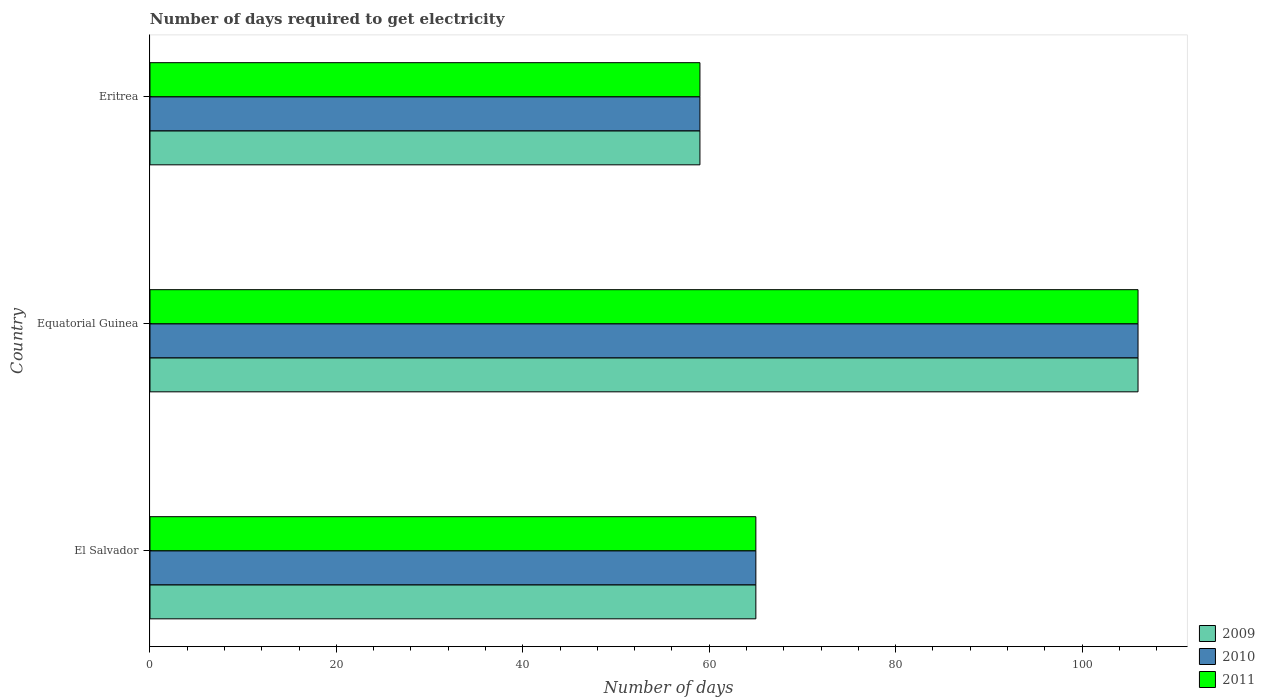How many different coloured bars are there?
Provide a short and direct response. 3. How many groups of bars are there?
Keep it short and to the point. 3. How many bars are there on the 2nd tick from the top?
Make the answer very short. 3. How many bars are there on the 2nd tick from the bottom?
Keep it short and to the point. 3. What is the label of the 3rd group of bars from the top?
Your response must be concise. El Salvador. Across all countries, what is the maximum number of days required to get electricity in in 2010?
Give a very brief answer. 106. Across all countries, what is the minimum number of days required to get electricity in in 2010?
Your response must be concise. 59. In which country was the number of days required to get electricity in in 2010 maximum?
Offer a terse response. Equatorial Guinea. In which country was the number of days required to get electricity in in 2010 minimum?
Give a very brief answer. Eritrea. What is the total number of days required to get electricity in in 2009 in the graph?
Ensure brevity in your answer.  230. What is the difference between the number of days required to get electricity in in 2009 in El Salvador and that in Equatorial Guinea?
Make the answer very short. -41. What is the difference between the number of days required to get electricity in in 2009 in Equatorial Guinea and the number of days required to get electricity in in 2011 in El Salvador?
Keep it short and to the point. 41. What is the average number of days required to get electricity in in 2009 per country?
Offer a very short reply. 76.67. In how many countries, is the number of days required to get electricity in in 2010 greater than 36 days?
Provide a short and direct response. 3. What is the ratio of the number of days required to get electricity in in 2009 in El Salvador to that in Equatorial Guinea?
Offer a terse response. 0.61. Is the number of days required to get electricity in in 2011 in El Salvador less than that in Eritrea?
Provide a short and direct response. No. What is the difference between the highest and the lowest number of days required to get electricity in in 2010?
Your answer should be very brief. 47. In how many countries, is the number of days required to get electricity in in 2011 greater than the average number of days required to get electricity in in 2011 taken over all countries?
Provide a succinct answer. 1. Is it the case that in every country, the sum of the number of days required to get electricity in in 2010 and number of days required to get electricity in in 2009 is greater than the number of days required to get electricity in in 2011?
Your answer should be very brief. Yes. How many bars are there?
Ensure brevity in your answer.  9. Does the graph contain any zero values?
Keep it short and to the point. No. How are the legend labels stacked?
Provide a succinct answer. Vertical. What is the title of the graph?
Your response must be concise. Number of days required to get electricity. What is the label or title of the X-axis?
Make the answer very short. Number of days. What is the label or title of the Y-axis?
Give a very brief answer. Country. What is the Number of days of 2009 in Equatorial Guinea?
Offer a very short reply. 106. What is the Number of days in 2010 in Equatorial Guinea?
Make the answer very short. 106. What is the Number of days of 2011 in Equatorial Guinea?
Give a very brief answer. 106. What is the Number of days in 2009 in Eritrea?
Give a very brief answer. 59. What is the Number of days of 2010 in Eritrea?
Your response must be concise. 59. What is the Number of days of 2011 in Eritrea?
Provide a succinct answer. 59. Across all countries, what is the maximum Number of days of 2009?
Ensure brevity in your answer.  106. Across all countries, what is the maximum Number of days in 2010?
Your answer should be compact. 106. Across all countries, what is the maximum Number of days of 2011?
Your response must be concise. 106. Across all countries, what is the minimum Number of days of 2009?
Make the answer very short. 59. Across all countries, what is the minimum Number of days in 2010?
Provide a succinct answer. 59. What is the total Number of days of 2009 in the graph?
Make the answer very short. 230. What is the total Number of days in 2010 in the graph?
Ensure brevity in your answer.  230. What is the total Number of days in 2011 in the graph?
Provide a succinct answer. 230. What is the difference between the Number of days of 2009 in El Salvador and that in Equatorial Guinea?
Your answer should be very brief. -41. What is the difference between the Number of days in 2010 in El Salvador and that in Equatorial Guinea?
Your answer should be compact. -41. What is the difference between the Number of days of 2011 in El Salvador and that in Equatorial Guinea?
Your response must be concise. -41. What is the difference between the Number of days of 2009 in El Salvador and that in Eritrea?
Make the answer very short. 6. What is the difference between the Number of days of 2011 in El Salvador and that in Eritrea?
Your response must be concise. 6. What is the difference between the Number of days of 2009 in Equatorial Guinea and that in Eritrea?
Give a very brief answer. 47. What is the difference between the Number of days in 2010 in Equatorial Guinea and that in Eritrea?
Offer a terse response. 47. What is the difference between the Number of days of 2011 in Equatorial Guinea and that in Eritrea?
Give a very brief answer. 47. What is the difference between the Number of days in 2009 in El Salvador and the Number of days in 2010 in Equatorial Guinea?
Keep it short and to the point. -41. What is the difference between the Number of days in 2009 in El Salvador and the Number of days in 2011 in Equatorial Guinea?
Provide a short and direct response. -41. What is the difference between the Number of days of 2010 in El Salvador and the Number of days of 2011 in Equatorial Guinea?
Offer a terse response. -41. What is the difference between the Number of days in 2009 in El Salvador and the Number of days in 2010 in Eritrea?
Offer a terse response. 6. What is the difference between the Number of days of 2010 in El Salvador and the Number of days of 2011 in Eritrea?
Make the answer very short. 6. What is the difference between the Number of days in 2009 in Equatorial Guinea and the Number of days in 2010 in Eritrea?
Offer a terse response. 47. What is the difference between the Number of days of 2010 in Equatorial Guinea and the Number of days of 2011 in Eritrea?
Your response must be concise. 47. What is the average Number of days of 2009 per country?
Keep it short and to the point. 76.67. What is the average Number of days in 2010 per country?
Your response must be concise. 76.67. What is the average Number of days of 2011 per country?
Your answer should be very brief. 76.67. What is the difference between the Number of days in 2009 and Number of days in 2011 in Equatorial Guinea?
Provide a succinct answer. 0. What is the difference between the Number of days in 2009 and Number of days in 2011 in Eritrea?
Your response must be concise. 0. What is the ratio of the Number of days of 2009 in El Salvador to that in Equatorial Guinea?
Give a very brief answer. 0.61. What is the ratio of the Number of days in 2010 in El Salvador to that in Equatorial Guinea?
Ensure brevity in your answer.  0.61. What is the ratio of the Number of days in 2011 in El Salvador to that in Equatorial Guinea?
Your answer should be very brief. 0.61. What is the ratio of the Number of days in 2009 in El Salvador to that in Eritrea?
Your answer should be compact. 1.1. What is the ratio of the Number of days in 2010 in El Salvador to that in Eritrea?
Provide a succinct answer. 1.1. What is the ratio of the Number of days in 2011 in El Salvador to that in Eritrea?
Offer a terse response. 1.1. What is the ratio of the Number of days of 2009 in Equatorial Guinea to that in Eritrea?
Give a very brief answer. 1.8. What is the ratio of the Number of days of 2010 in Equatorial Guinea to that in Eritrea?
Your response must be concise. 1.8. What is the ratio of the Number of days in 2011 in Equatorial Guinea to that in Eritrea?
Your answer should be very brief. 1.8. What is the difference between the highest and the second highest Number of days of 2009?
Keep it short and to the point. 41. What is the difference between the highest and the second highest Number of days of 2010?
Give a very brief answer. 41. What is the difference between the highest and the lowest Number of days of 2009?
Keep it short and to the point. 47. What is the difference between the highest and the lowest Number of days in 2011?
Make the answer very short. 47. 